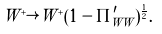<formula> <loc_0><loc_0><loc_500><loc_500>W ^ { + } \rightarrow W ^ { + } ( 1 - \Pi ^ { \prime } _ { W W } ) ^ { \frac { 1 } { 2 } } .</formula> 